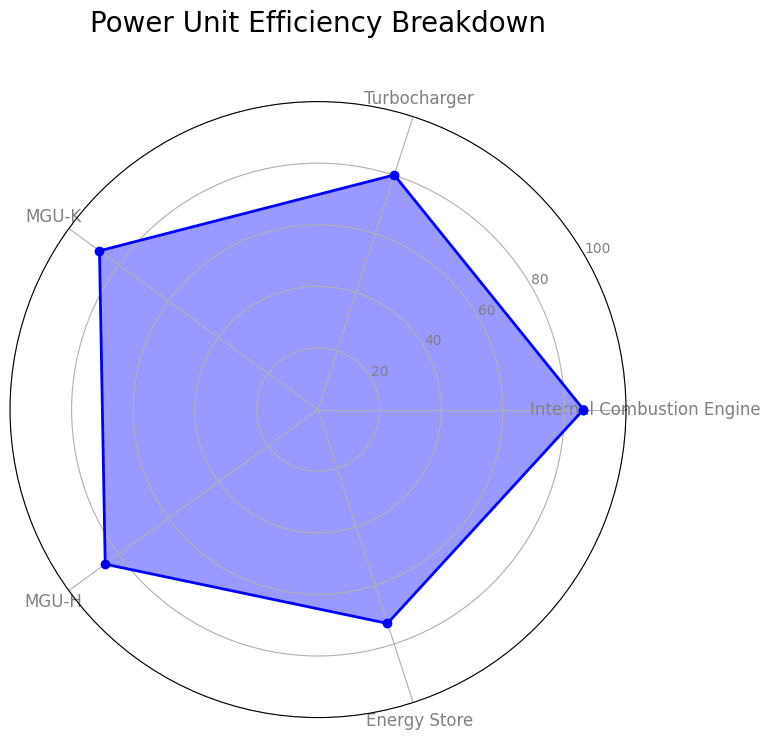What is the average efficiency value for the Internal Combustion Engine? To calculate the average, sum all the values for the Internal Combustion Engine and divide by the number of data points: (85 + 88 + 84 + 87 + 86 + 85 + 89 + 84 + 88 + 86) / 10 = 862 / 10 = 86.2
Answer: 86.2 Which component has the highest efficiency on average? To determine this, calculate the average efficiency for each component by summing their respective values and dividing by the number of data points. The Internal Combustion Engine has an average of 86.2, Turbocharger 80.1, MGU-K 87.7, MGU-H 85.4, and Energy Store 73.1. The MGU-K has the highest average efficiency.
Answer: MGU-K Which component has the lowest efficiency on average? By calculating the average efficiency for each component, it is observed that the Energy Store has the lowest average efficiency of 73.1.
Answer: Energy Store What is the difference between the highest and lowest average efficiency values? The highest average efficiency is 87.7 (MGU-K) and the lowest is 73.1 (Energy Store). The difference is 87.7 - 73.1 = 14.6.
Answer: 14.6 Compare the average efficiencies of the Internal Combustion Engine and Turbocharger. Which one is higher and by how much? The average efficiency for the Internal Combustion Engine is 86.2 and for the Turbocharger is 80.1. The Internal Combustion Engine is higher by 86.2 - 80.1 = 6.1.
Answer: Internal Combustion Engine by 6.1 Which two components have the closest average efficiencies? The average efficiencies are Internal Combustion Engine (86.2), Turbocharger (80.1), MGU-K (87.7), MGU-H (85.4), and Energy Store (73.1). The closest values are Internal Combustion Engine (86.2) and MGU-H (85.4), with a difference of 0.8.
Answer: Internal Combustion Engine and MGU-H What is the median value of the Efficiency for MGU-K? The values for MGU-K are: [90, 85, 87, 89, 88, 91, 86, 89, 85, 87]. Sort these values: [85, 85, 86, 87, 87, 88, 89, 89, 90, 91]. The median value, being the average of the two middle values (87 and 88), is (87 + 88) / 2 = 87.5.
Answer: 87.5 Which efficiency category has the largest variability? Variability can be determined by calculating the standard deviation for each category. Based on visual inspection of the values, MGU-K shows a wide range, but precise calculation is best for accuracy.
Answer: MGU-K 